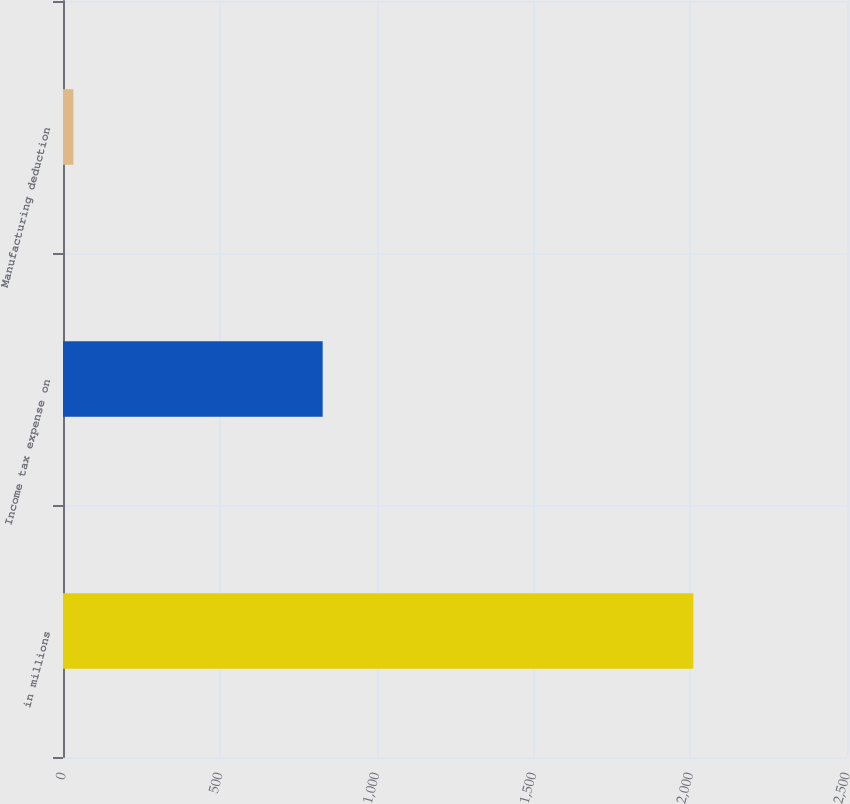<chart> <loc_0><loc_0><loc_500><loc_500><bar_chart><fcel>in millions<fcel>Income tax expense on<fcel>Manufacturing deduction<nl><fcel>2010<fcel>828<fcel>33<nl></chart> 